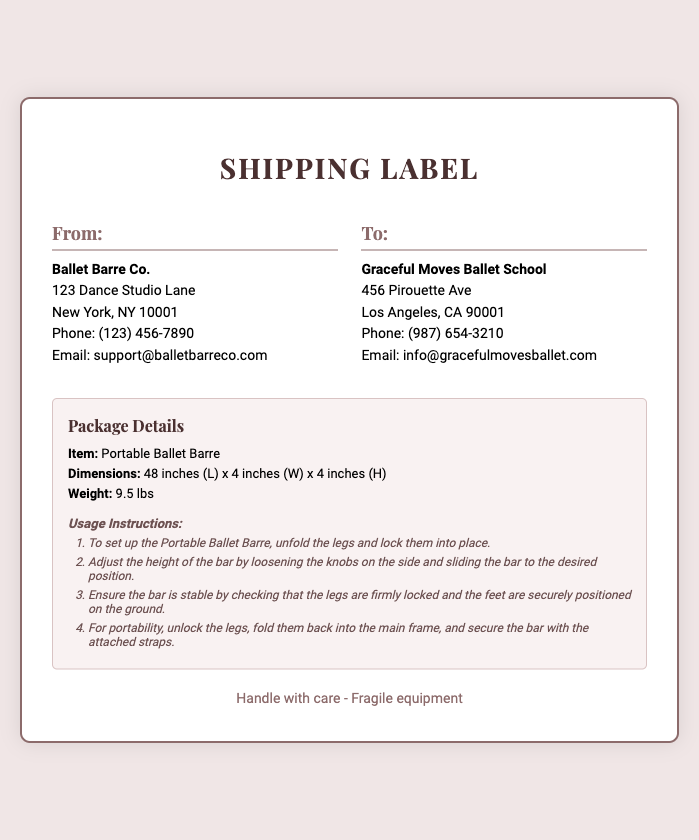what is the item being shipped? The document lists "Portable Ballet Barre" as the item being shipped.
Answer: Portable Ballet Barre what are the dimensions of the item? The dimensions are provided in the document as 48 inches (L) x 4 inches (W) x 4 inches (H).
Answer: 48 inches (L) x 4 inches (W) x 4 inches (H) what is the weight of the package? The weight of the package is explicitly stated in the document.
Answer: 9.5 lbs who is the sender mentioned in the document? The sender's details are provided as "Ballet Barre Co." with an address.
Answer: Ballet Barre Co what is the first step in the usage instructions? The initial step for setup is described in the instructions.
Answer: To set up the Portable Ballet Barre, unfold the legs and lock them into place how many steps are in the usage instructions? The document lists a sequence in the usage instructions.
Answer: Four what is the phone number for the recipient? The recipient's contact number is listed in the address section.
Answer: (987) 654-3210 what is the email address for the sender? The document provides the sender’s contact email.
Answer: support@balletbarreco.com what warning is mentioned in the footer? The footer contains a warning regarding the item.
Answer: Handle with care - Fragile equipment 